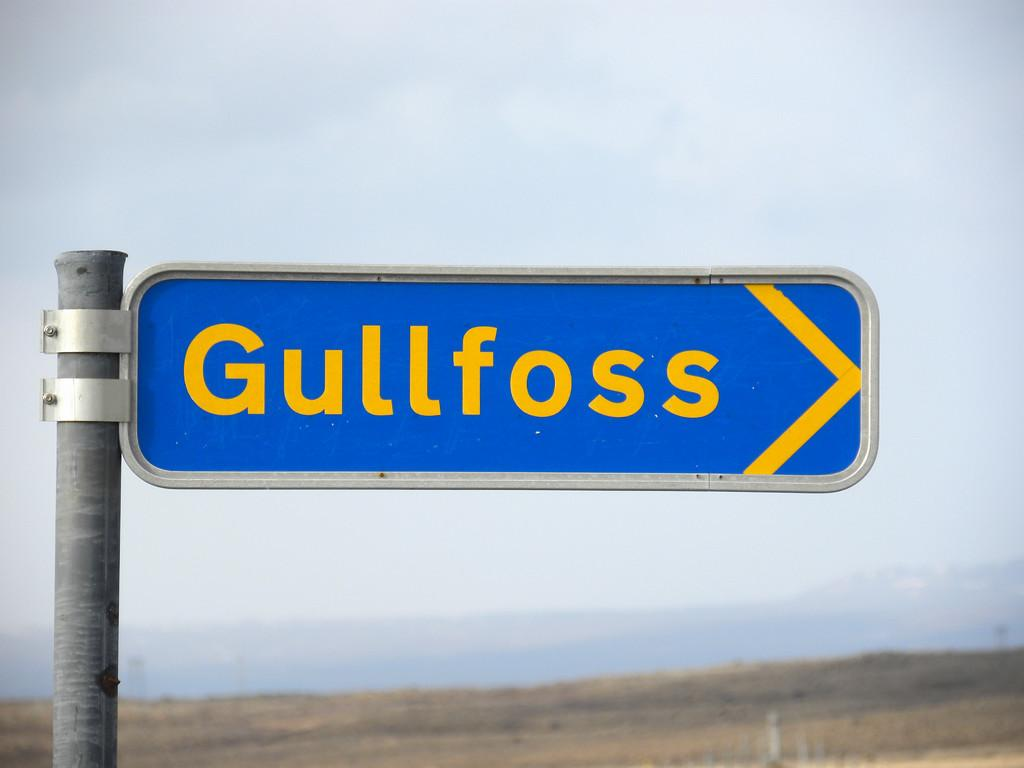<image>
Give a short and clear explanation of the subsequent image. a blue sign has the word Gullfoss written in yellow 